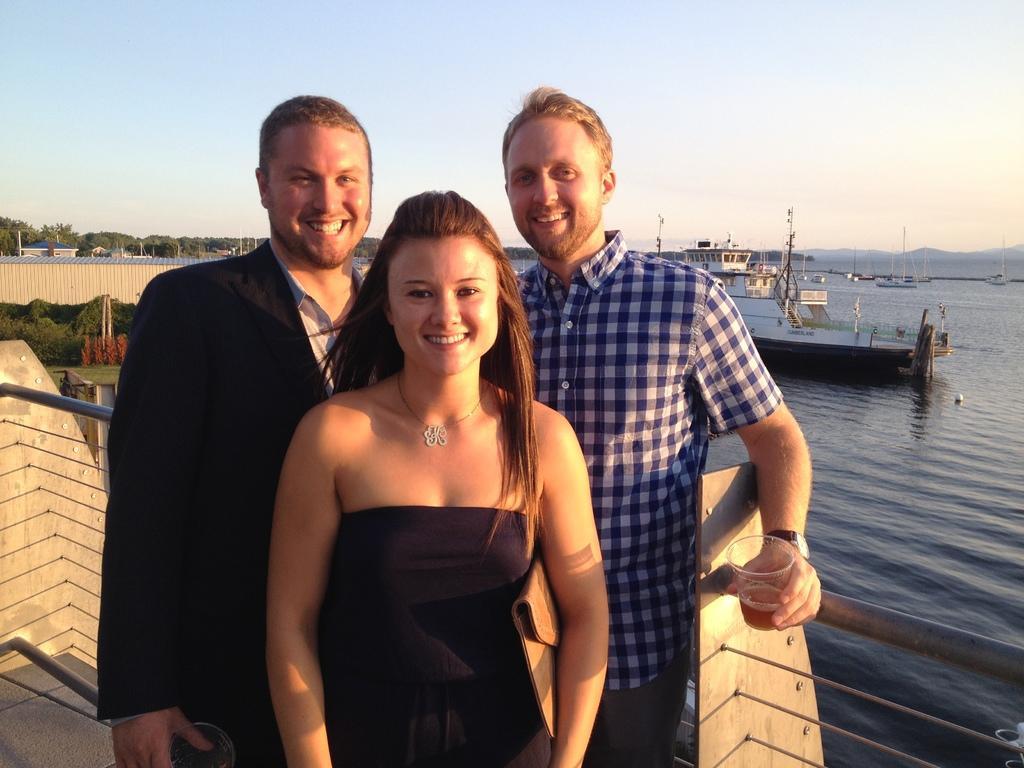How would you summarize this image in a sentence or two? This image is taken outdoors. At the top of the image there is the sky. In the background there are many trees. There are a few houses with walls. There is a ship on the river. There are a few boats on the river. In the middle of the image two men and a woman are standing on the floor and they are with smiling faces. Two men are holding glasses in their hands. There is a railing and there are a few iron bars. 